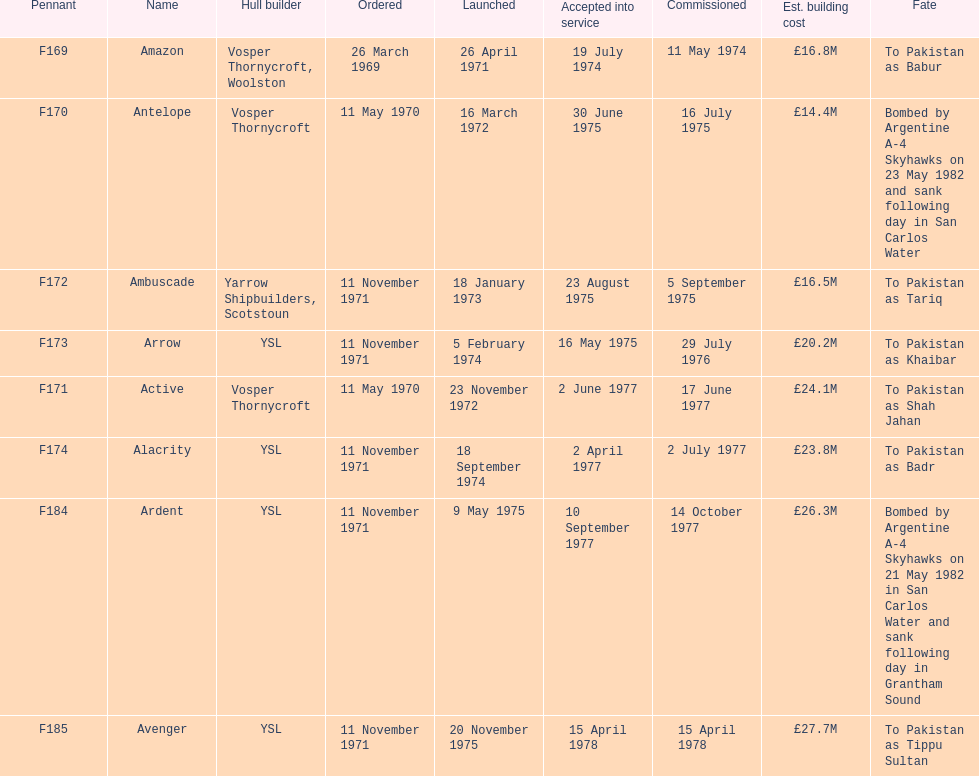What is the concluding family name shown on this graph? Avenger. 